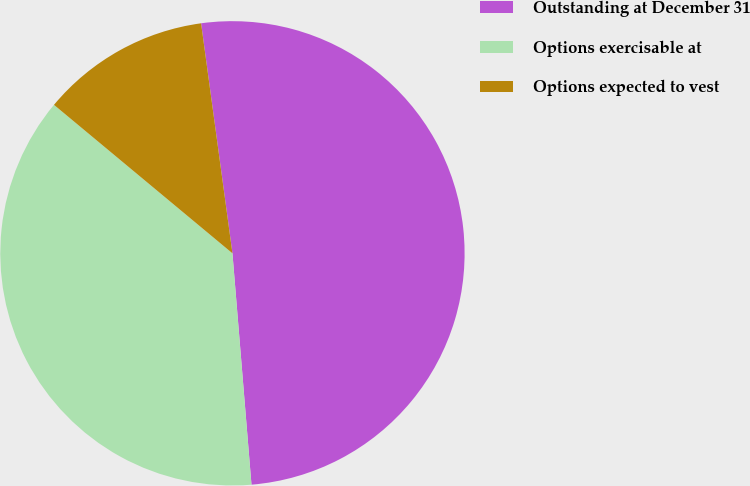Convert chart. <chart><loc_0><loc_0><loc_500><loc_500><pie_chart><fcel>Outstanding at December 31<fcel>Options exercisable at<fcel>Options expected to vest<nl><fcel>50.85%<fcel>37.35%<fcel>11.8%<nl></chart> 